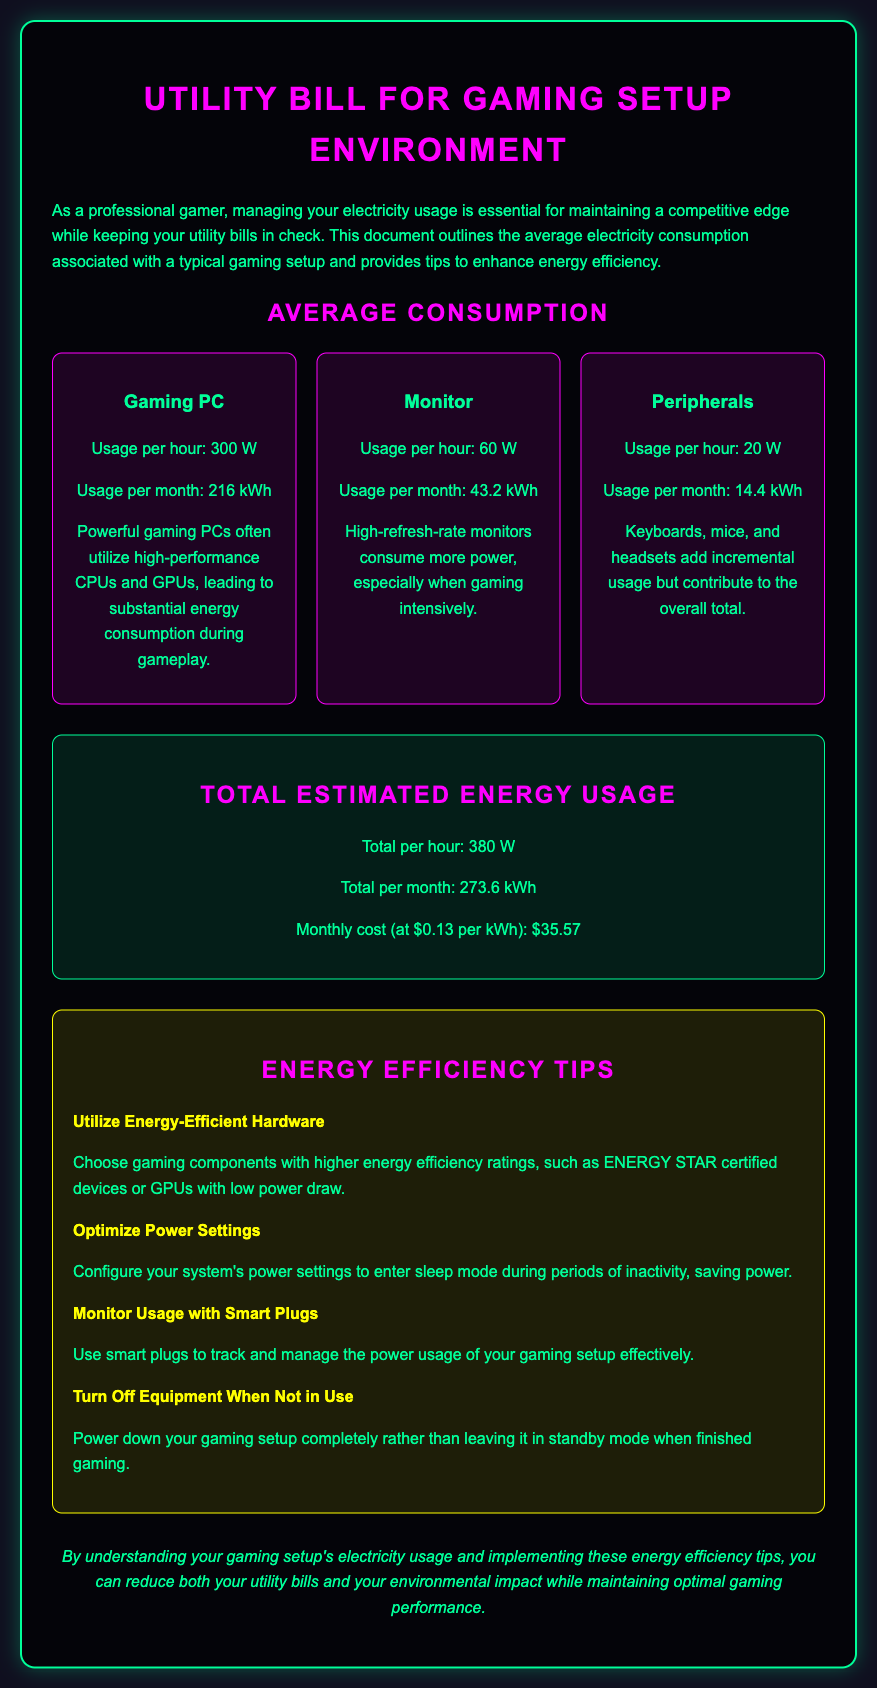What is the usage per hour for a gaming PC? The usage per hour for a gaming PC is specified as 300 W in the document.
Answer: 300 W What is the total estimated energy usage per month? The document states that the total estimated energy usage per month is 273.6 kWh.
Answer: 273.6 kWh What is the monthly cost of electricity at $0.13 per kWh? The monthly cost is calculated as $35.57 based on the total usage and cost per kWh stated in the document.
Answer: $35.57 How much power do peripherals use per hour? The document indicates that peripherals use 20 W per hour.
Answer: 20 W What is one way to save power mentioned in the tips section? The tips section suggests utilizing energy-efficient hardware, which helps in saving power.
Answer: Utilize energy-efficient hardware What is the usage per month for a monitor? According to the document, the usage per month for a monitor is 43.2 kWh.
Answer: 43.2 kWh What is the total power usage per hour for the entire setup? The document specifies that the total power usage per hour is 380 W for the entire gaming setup.
Answer: 380 W What type of hardware does the document suggest should be chosen for energy efficiency? The document mentions that gaming components with higher energy efficiency ratings should be chosen.
Answer: Higher energy efficiency ratings 